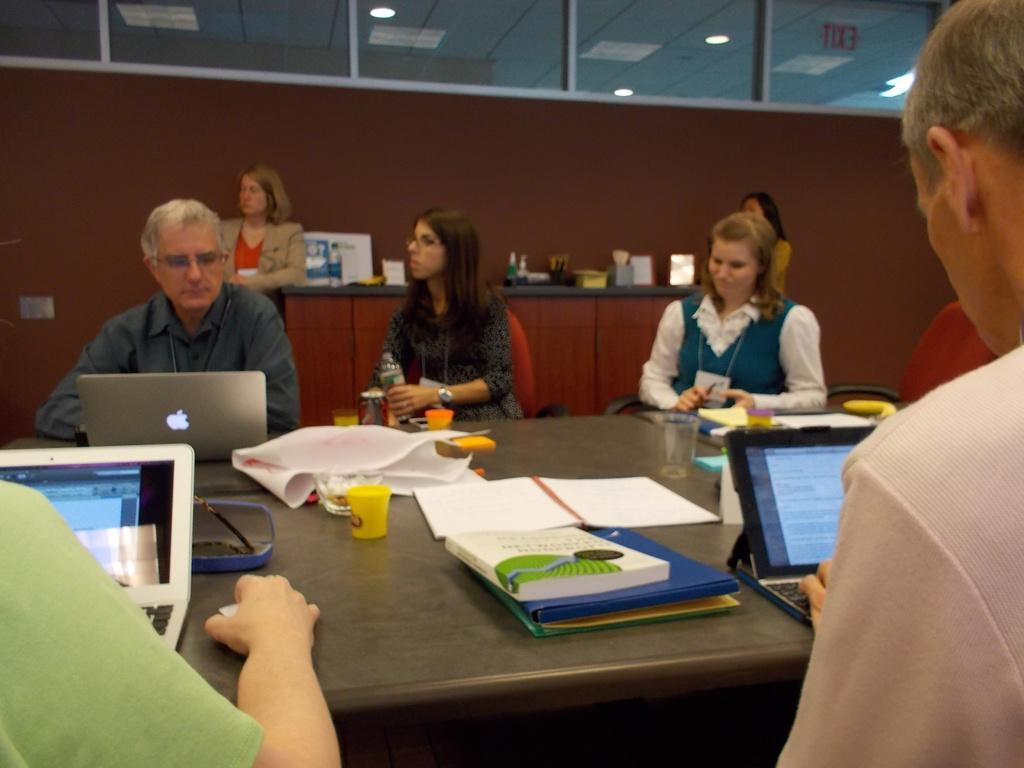Please provide a concise description of this image. In this image there are many people. In the front it consists of a table which has two laptops and people operating it. The table also consists of a book in the center and a glass. There are three people sitting in the opposite direction. The person at the left is wearing a grey shirt and operating apple laptop. The woman behind that man is suited up. 